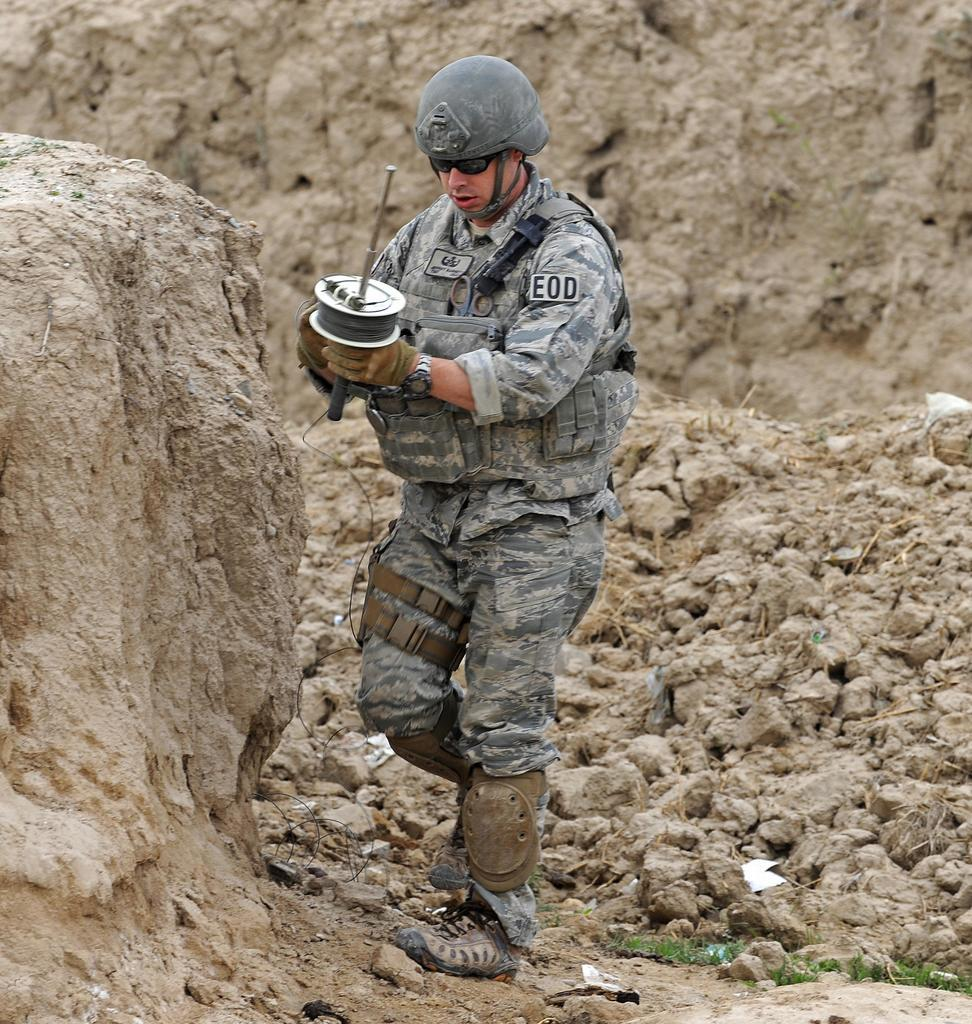Who is the main subject in the image? There is a man in the center of the image. What is the man doing in the image? The man is standing in the image. What is the man holding in the image? The man is holding something in the image. What type of terrain is visible at the bottom of the image? There are rocks at the bottom of the image. What can be seen in the distance in the image? There is a mountain in the background of the image. Where is the playground located in the image? There is no playground present in the image. What type of error is visible in the image? There is no error visible in the image; it appears to be a clear and accurate representation of the scene. 